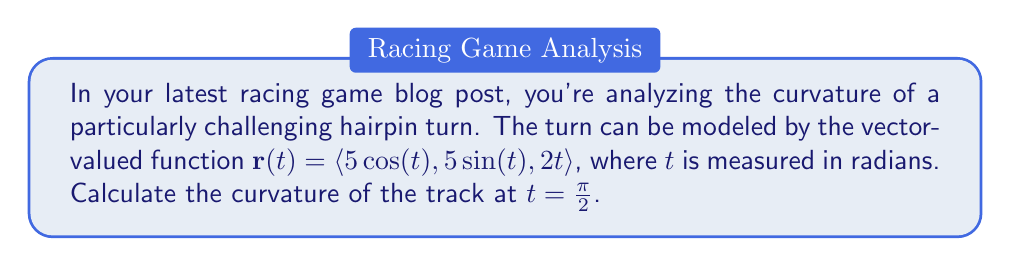Can you answer this question? To calculate the curvature of the race track, we'll use the formula for curvature of a vector-valued function:

$$\kappa = \frac{|\mathbf{r}'(t) \times \mathbf{r}''(t)|}{|\mathbf{r}'(t)|^3}$$

Let's break this down step-by-step:

1) First, we need to find $\mathbf{r}'(t)$:
   $$\mathbf{r}'(t) = \langle -5\sin(t), 5\cos(t), 2 \rangle$$

2) Next, we calculate $\mathbf{r}''(t)$:
   $$\mathbf{r}''(t) = \langle -5\cos(t), -5\sin(t), 0 \rangle$$

3) Now, we need to evaluate these at $t = \frac{\pi}{2}$:
   $$\mathbf{r}'(\frac{\pi}{2}) = \langle -5, 0, 2 \rangle$$
   $$\mathbf{r}''(\frac{\pi}{2}) = \langle 0, -5, 0 \rangle$$

4) We need to calculate the cross product $\mathbf{r}'(\frac{\pi}{2}) \times \mathbf{r}''(\frac{\pi}{2})$:
   $$\mathbf{r}'(\frac{\pi}{2}) \times \mathbf{r}''(\frac{\pi}{2}) = \langle 10, 0, 25 \rangle$$

5) The magnitude of this cross product is:
   $$|\mathbf{r}'(\frac{\pi}{2}) \times \mathbf{r}''(\frac{\pi}{2})| = \sqrt{10^2 + 0^2 + 25^2} = \sqrt{725}$$

6) We also need $|\mathbf{r}'(\frac{\pi}{2})|^3$:
   $$|\mathbf{r}'(\frac{\pi}{2})|^3 = (\sqrt{(-5)^2 + 0^2 + 2^2})^3 = (\sqrt{29})^3 = 29\sqrt{29}$$

7) Finally, we can plug these values into our curvature formula:
   $$\kappa = \frac{\sqrt{725}}{29\sqrt{29}}$$

8) Simplifying:
   $$\kappa = \frac{\sqrt{725}}{29\sqrt{29}} = \frac{\sqrt{25 \cdot 29}}{29\sqrt{29}} = \frac{5\sqrt{29}}{29\sqrt{29}} = \frac{5}{29}$$
Answer: $\kappa = \frac{5}{29}$ 